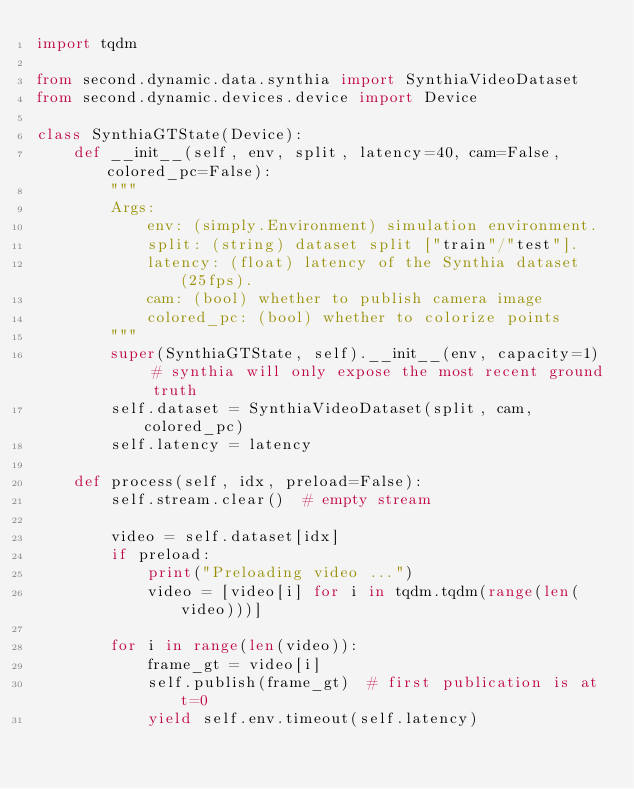<code> <loc_0><loc_0><loc_500><loc_500><_Python_>import tqdm

from second.dynamic.data.synthia import SynthiaVideoDataset
from second.dynamic.devices.device import Device

class SynthiaGTState(Device):
    def __init__(self, env, split, latency=40, cam=False, colored_pc=False):
        """
        Args:
            env: (simply.Environment) simulation environment.
            split: (string) dataset split ["train"/"test"].
            latency: (float) latency of the Synthia dataset (25fps).
            cam: (bool) whether to publish camera image
            colored_pc: (bool) whether to colorize points
        """
        super(SynthiaGTState, self).__init__(env, capacity=1)  # synthia will only expose the most recent ground truth
        self.dataset = SynthiaVideoDataset(split, cam, colored_pc)
        self.latency = latency
    
    def process(self, idx, preload=False):
        self.stream.clear()  # empty stream

        video = self.dataset[idx]
        if preload:
            print("Preloading video ...")
            video = [video[i] for i in tqdm.tqdm(range(len(video)))]

        for i in range(len(video)):
            frame_gt = video[i]
            self.publish(frame_gt)  # first publication is at t=0
            yield self.env.timeout(self.latency)
</code> 